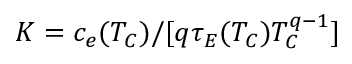Convert formula to latex. <formula><loc_0><loc_0><loc_500><loc_500>K = c _ { e } ( T _ { C } ) / [ q \tau _ { E } ( T _ { C } ) T _ { C } ^ { q - 1 } ]</formula> 